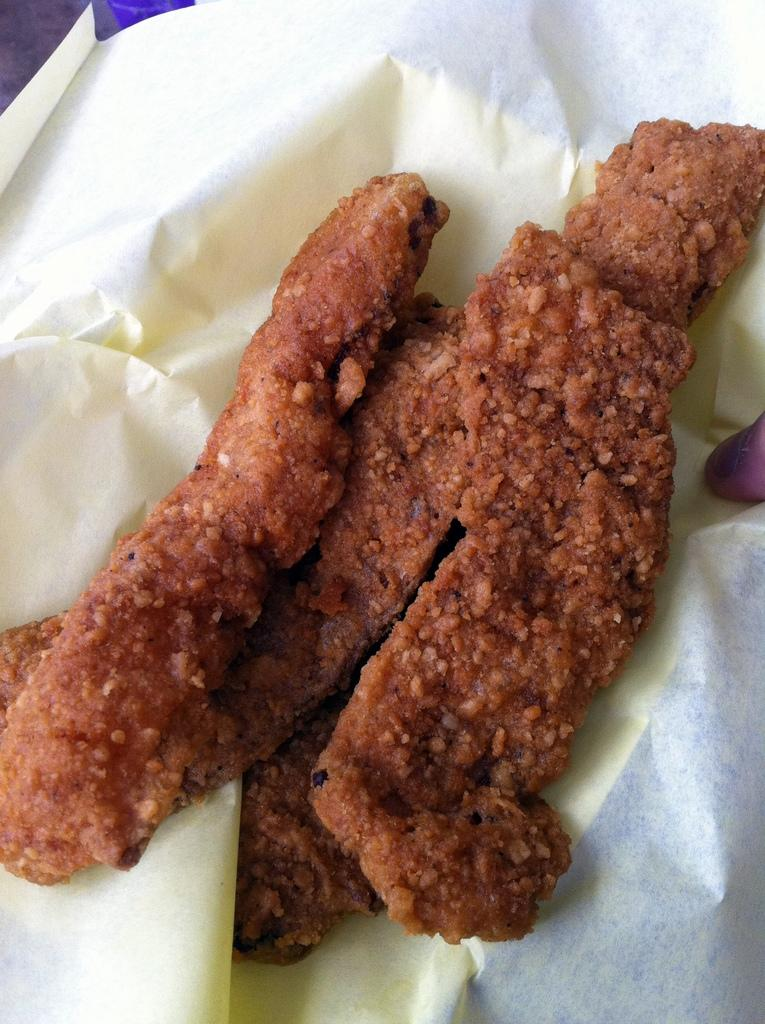What is the main subject of the image? There is a food item in the center of the image. How is the food item presented? The food item is on a paper. Can you describe any other elements in the image? There is a person's finger visible on the right side of the image. What time of day is it in the image, considering the presence of the parent and the car? There is no mention of a parent or a car in the image, so it is not possible to determine the time of day based on these elements. 